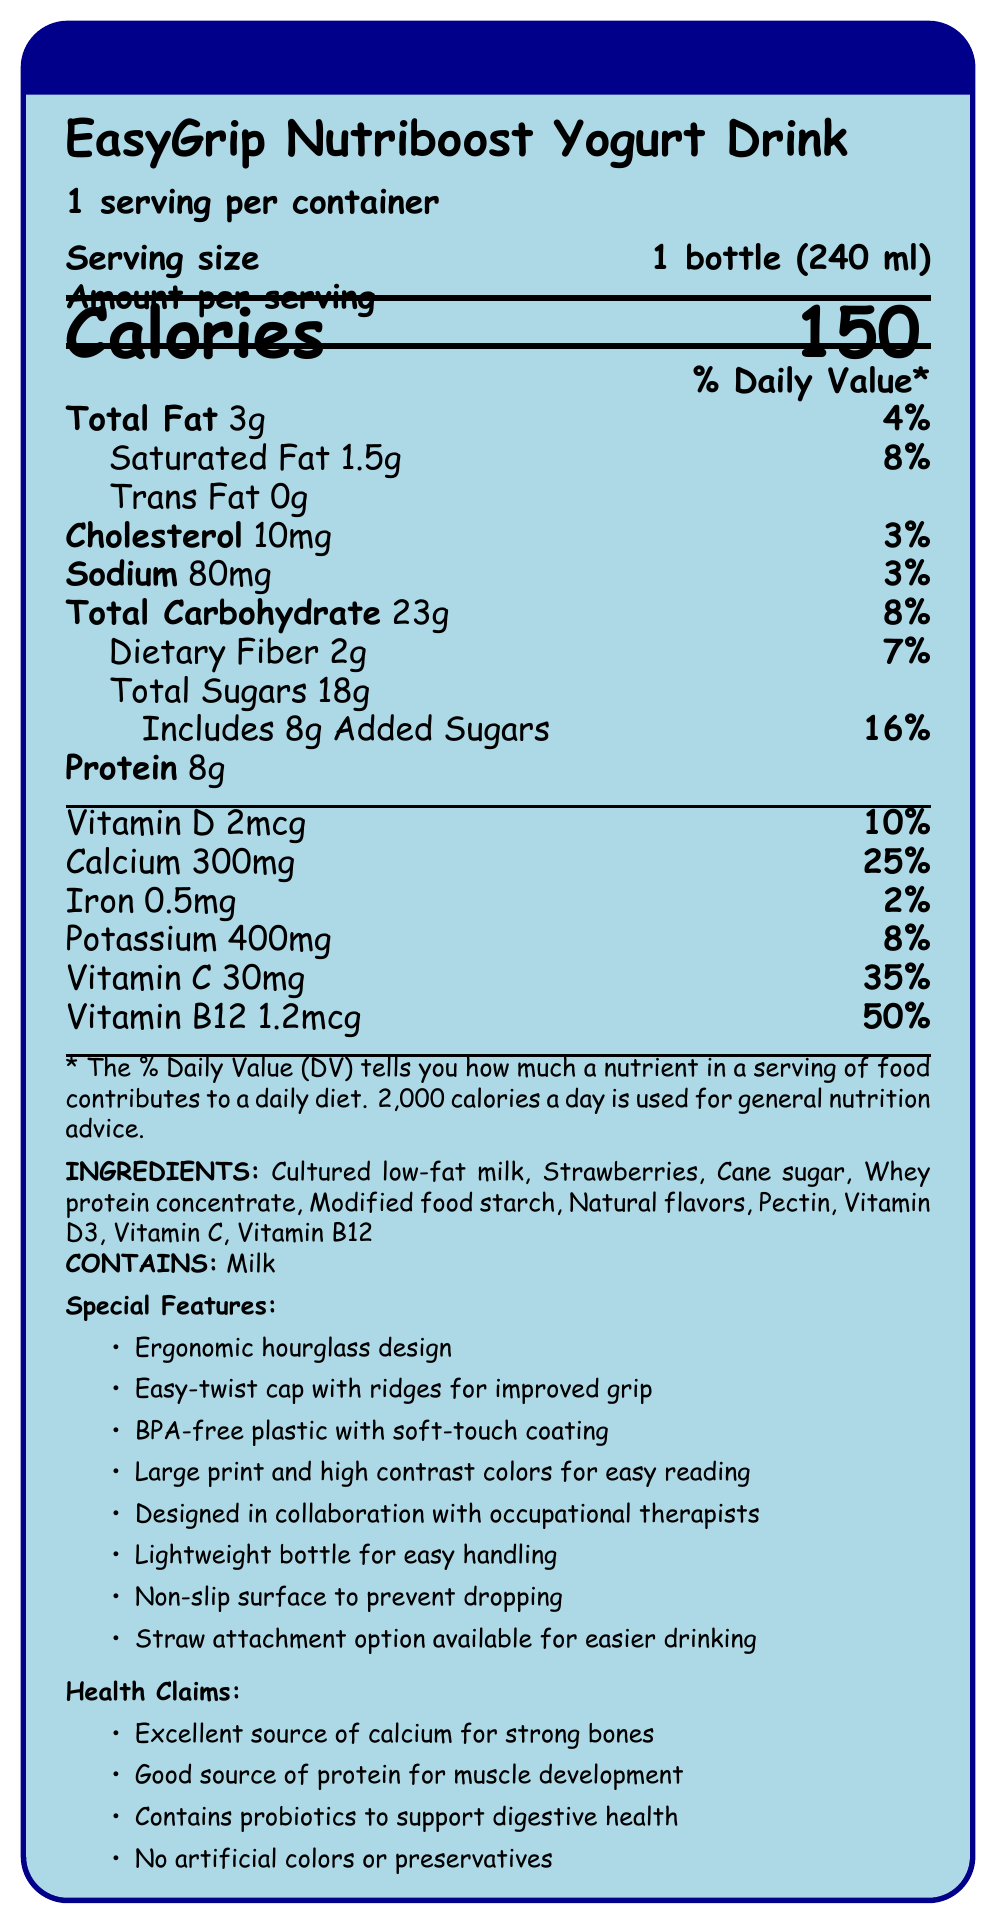what is the serving size? The serving size is mentioned as "1 bottle (240 ml)" in the document.
Answer: 1 bottle (240 ml) how many calories are in one serving? The document states that there are 150 calories per serving.
Answer: 150 how much protein does the yogurt drink contain? The document lists the protein content as 8g.
Answer: 8g what is the amount of total sugars in the drink? The "Total Sugars" section specifies that the amount is 18g.
Answer: 18g what is the daily value percentage for calcium? The document indicates that the daily value percentage for calcium is 25%.
Answer: 25% which of the following vitamins is present in the highest amount? A. Vitamin D B. Vitamin C C. Vitamin B12 According to the amounts listed, Vitamin B12 (1.2mcg, 50% DV) is present in the highest daily value percentage.
Answer: C. Vitamin B12 what is the total amount of fat including both saturated and trans fat? A. 3g B. 4.5g C. 4g The document lists "Total Fat" as 3g. Saturated fat (1.5g) and trans fat (0g) are part of this total.
Answer: A. 3g does the product contain any artificial colors or preservatives? The health claims section explicitly states "No artificial colors or preservatives."
Answer: No does the product contain peanuts? The allergen information specifies that it contains milk, and there is no mention of peanuts.
Answer: No summarize the main features and nutritional information of the yogurt drink. This summary covers the main aspects of the product, including its nutritional information, special features designed for easier handling, and the health benefits claimed by the product.
Answer: The EasyGrip Nutriboost Yogurt Drink is a nutrient-dense yogurt drink designed with an ergonomic hourglass bottle and easy-to-twist cap for better handling. It has 150 calories per serving, 3g of total fat, 8g of protein, and is nutrient-rich with vitamins and minerals such as calcium and vitamins B12, C, and D. The product includes health claims like promoting strong bones, muscle development, and digestive health. what type of milk is used in the ingredients? The ingredients list shows that "Cultured low-fat milk" is used.
Answer: Cultured low-fat milk how much potassium is in one serving? The document lists potassium content as 400mg.
Answer: 400mg what materials is the bottle made from? A. Glass B. BPA-free plastic C. Aluminum The container features state that the material used is "BPA-free plastic."
Answer: B. BPA-free plastic how much added sugar is in the yogurt drink? The document indicates that added sugars amount to 8g.
Answer: 8g are probiotics included in the yogurt drink? The health claims mention that the product "Contains probiotics to support digestive health."
Answer: Yes is the yogurt drink suitable for children with milk allergies? The allergen information specifies that the product contains milk, making it unsuitable for children with milk allergies.
Answer: No can it be determined how many bottles are in a pack? The document only mentions "1 serving per container" without indicating the number of bottles in a pack.
Answer: Not enough information 